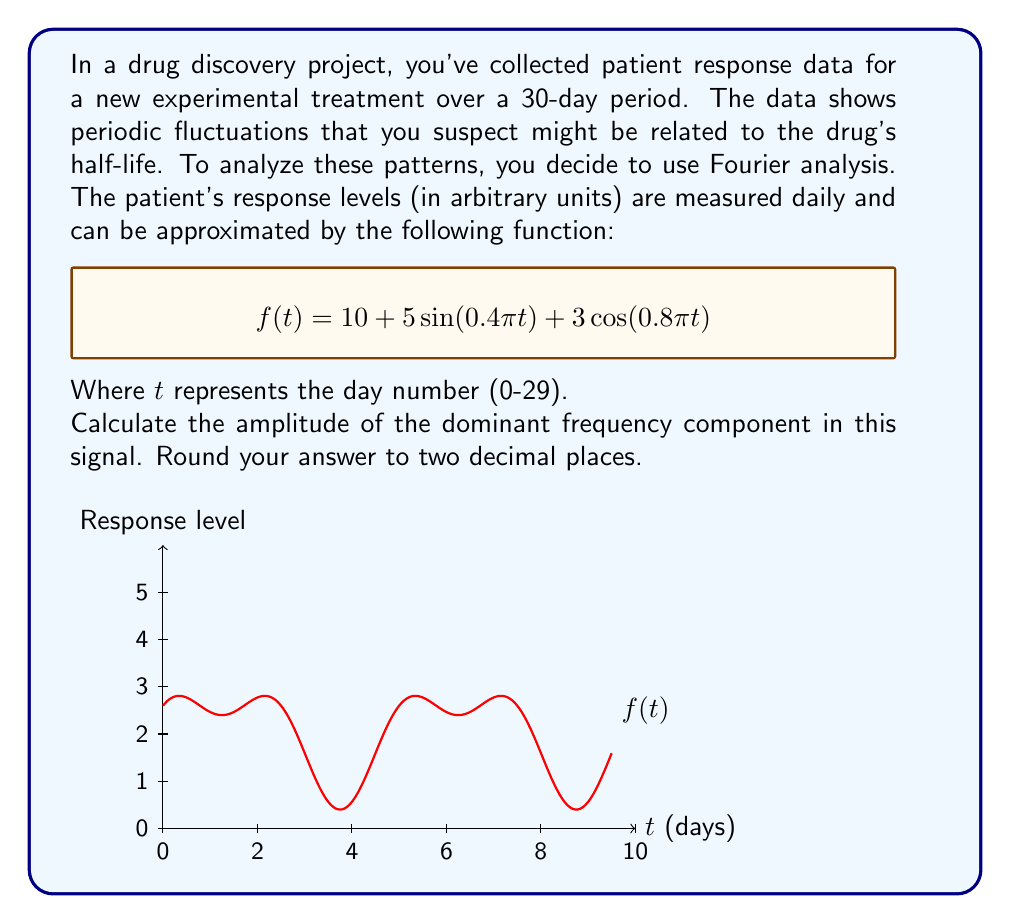Provide a solution to this math problem. To find the amplitude of the dominant frequency component, we need to follow these steps:

1) First, we identify the sinusoidal components in the given function:
   $$f(t) = 10 + 5\sin(0.4\pi t) + 3\cos(0.8\pi t)$$

2) The constant term 10 doesn't contribute to the periodic behavior, so we focus on:
   $$5\sin(0.4\pi t) + 3\cos(0.8\pi t)$$

3) These terms represent two different frequency components:
   - $5\sin(0.4\pi t)$ has frequency $0.2$ cycles/day and amplitude 5
   - $3\cos(0.8\pi t)$ has frequency $0.4$ cycles/day and amplitude 3

4) The dominant frequency component is the one with the larger amplitude, which is $5\sin(0.4\pi t)$.

5) Therefore, the amplitude of the dominant frequency component is 5.

Rounding to two decimal places gives us 5.00.
Answer: 5.00 